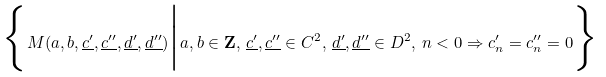<formula> <loc_0><loc_0><loc_500><loc_500>\Big \{ M ( a , b , \underline { c ^ { \prime } } , \underline { c ^ { \prime \prime } } , \underline { d ^ { \prime } } , \underline { d ^ { \prime \prime } } ) \Big | a , b \in \mathbf Z , \, \underline { c ^ { \prime } } , \underline { c ^ { \prime \prime } } \in C ^ { 2 } , \, \underline { d ^ { \prime } } , \underline { d ^ { \prime \prime } } \in D ^ { 2 } , \, n < 0 \Rightarrow c ^ { \prime } _ { n } = c ^ { \prime \prime } _ { n } = 0 \Big \}</formula> 